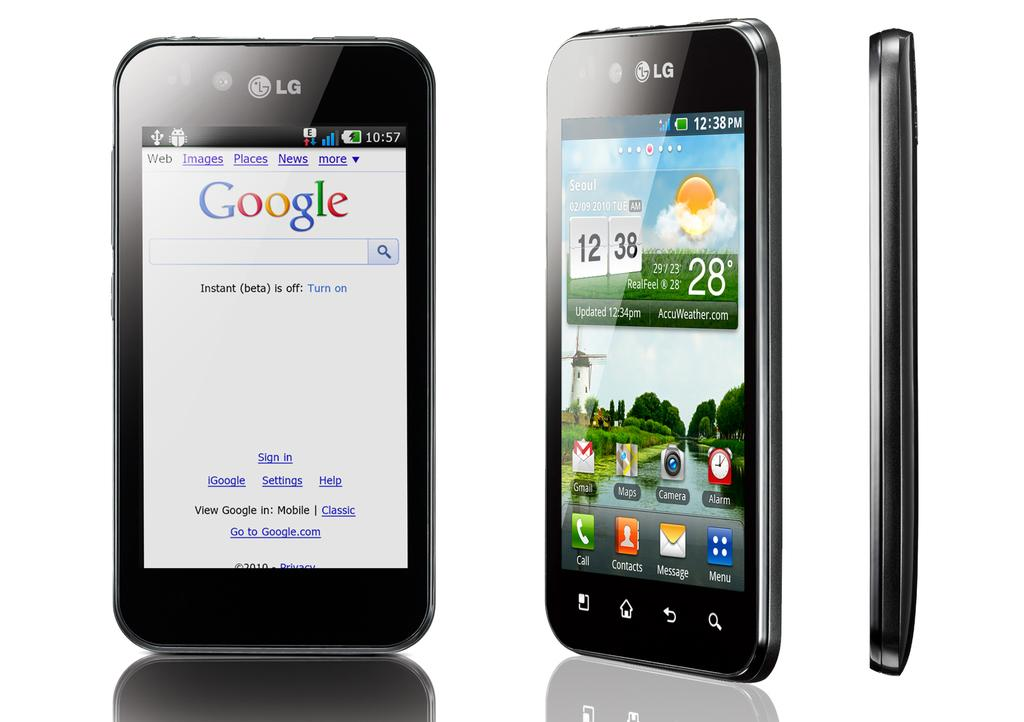Provide a one-sentence caption for the provided image. An image of a phone taken at 12:38 on a 28° day. 